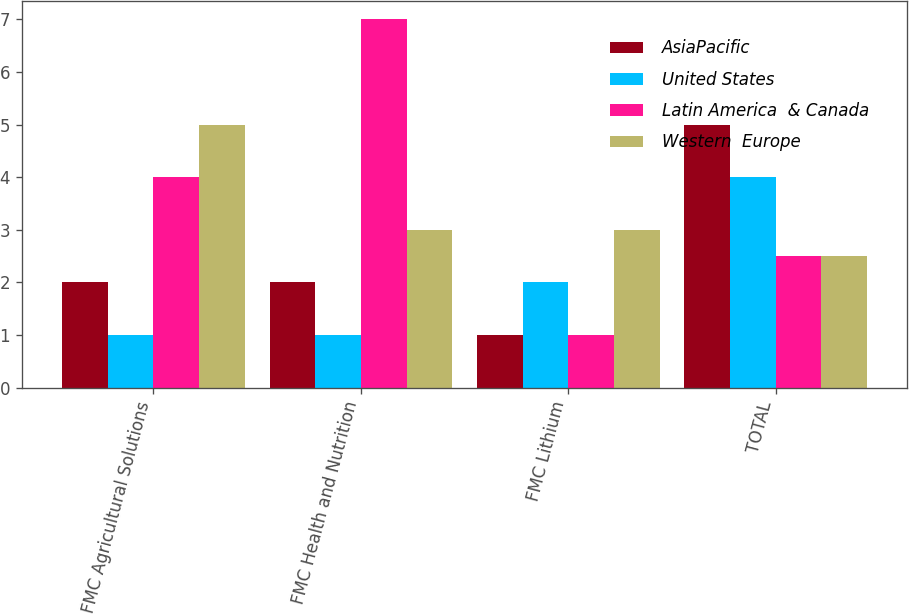Convert chart. <chart><loc_0><loc_0><loc_500><loc_500><stacked_bar_chart><ecel><fcel>FMC Agricultural Solutions<fcel>FMC Health and Nutrition<fcel>FMC Lithium<fcel>TOTAL<nl><fcel>AsiaPacific<fcel>2<fcel>2<fcel>1<fcel>5<nl><fcel>United States<fcel>1<fcel>1<fcel>2<fcel>4<nl><fcel>Latin America  & Canada<fcel>4<fcel>7<fcel>1<fcel>2.5<nl><fcel>Western  Europe<fcel>5<fcel>3<fcel>3<fcel>2.5<nl></chart> 